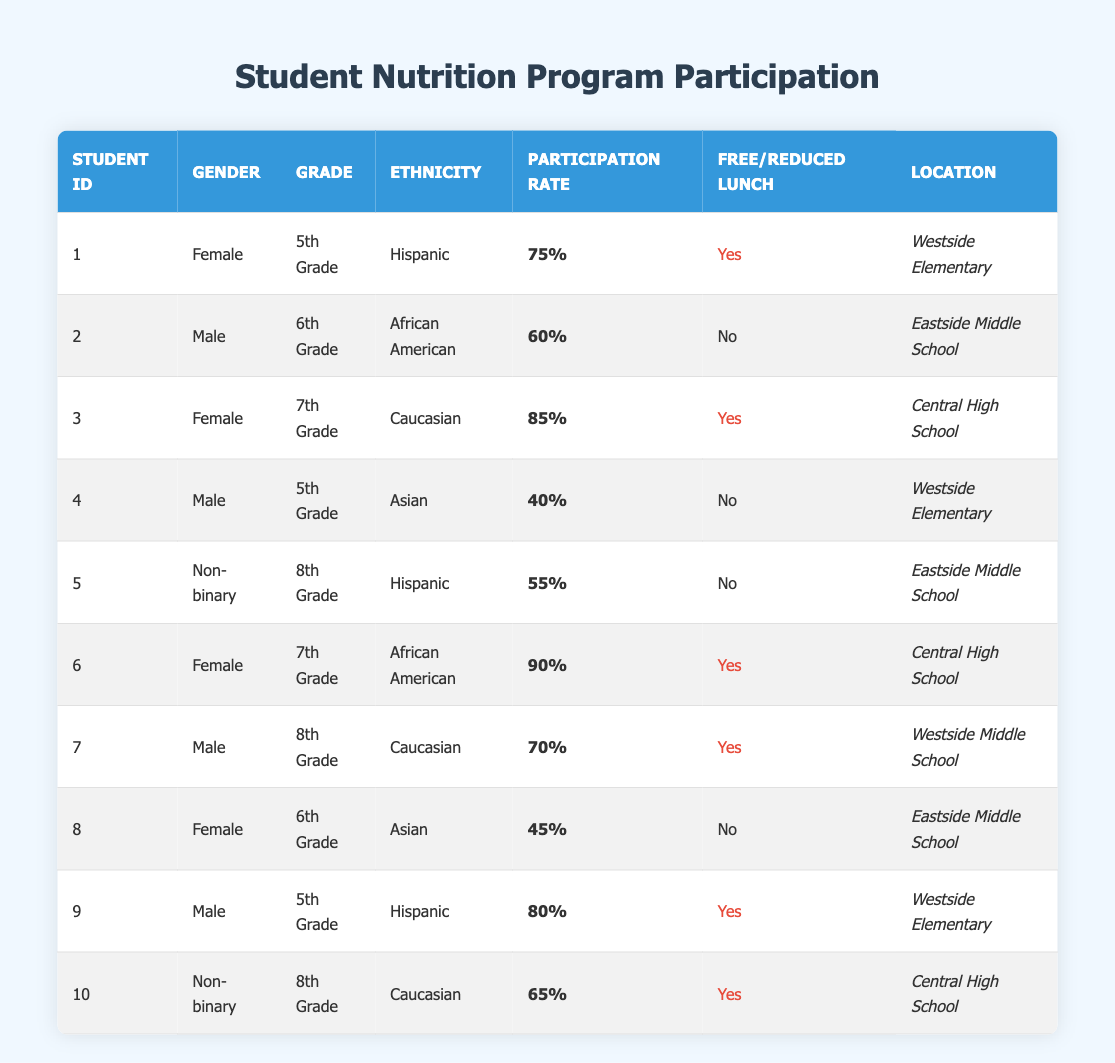What is the participation rate of the female students? From the table, the participation rates for female students are 75% (student 1), 85% (student 3), 90% (student 6), and 45% (student 8). To find the average, we sum these rates: 75 + 85 + 90 + 45 = 295. There are 4 female students, so the average participation rate is 295/4 = 73.75%.
Answer: 73.75% How many students participated in the nutrition program at Eastside Middle School? Looking at the table, there are two students from Eastside Middle School (student 2 and student 5). Both participated in the nutrition program, so the total number of participants is 2.
Answer: 2 Which student has the highest participation rate? Examining the participation rates in the table, the highest participation rate is 90%, held by student 6 (Female, 7th Grade, African American) at Central High School.
Answer: Student 6 What percentage of students who receive free/reduced lunch participated in the program? There are 5 students who receive free/reduced lunch (students 1, 3, 6, 7, and 9) with participation rates of 75%, 85%, 90%, 70%, and 80%. The total number of students with free/reduced lunch is 5. To find the average, we sum the rates: 75 + 85 + 90 + 70 + 80 = 400, and then divide by 5 to get 400/5 = 80%.
Answer: 80% Is the participation rate of Hispanic students generally higher than that of Asian students? The participation rates for Hispanic students (student 1, 5, and 9) are 75%, 55%, and 80% respectively, averaging (75 + 55 + 80) / 3 = 70%. For Asian students (student 4 and 8), the rates are 40% and 45%, averaging (40 + 45) / 2 = 42.5%. Since 70% is greater than 42.5%, Hispanic students have a higher average participation rate.
Answer: Yes What locations have the highest number of participants in the program? From the table, we identify the locations: Westside Elementary has 3 students, Eastside Middle School has 2 students, and Central High School has 3 students. Both Westside Elementary and Central High School have the highest number, with 3 participants each.
Answer: Westside Elementary and Central High School What is the median participation rate of all students? To find the median, we first list all participation rates: 75%, 60%, 85%, 40%, 55%, 90%, 70%, 45%, 80%, 65%. Sorted, the rates are: 40%, 45%, 55%, 60%, 65%, 70%, 75%, 80%, 85%, 90%. Since there are 10 rates, the median will be the average of the 5th (65%) and the 6th (70%) values: (65 + 70) / 2 = 67.5%.
Answer: 67.5% How many students in 8th Grade participated in the nutrition program? There are 2 students in 8th Grade, student 5 (participation rate 55%) and student 10 (participation rate 65%). Therefore, the number of 8th Grade students who participated is 2.
Answer: 2 What is the participation rate of Caucasian students overall? The participation rates for Caucasian students are 85% (student 3) and 65% (student 10). The average rate is (85 + 65) / 2 = 75%.
Answer: 75% 